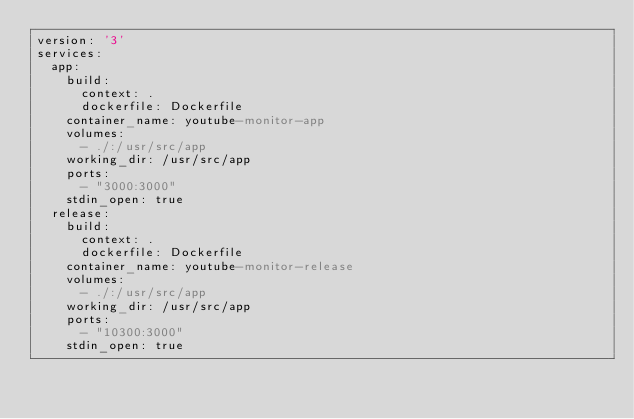<code> <loc_0><loc_0><loc_500><loc_500><_YAML_>version: '3'
services:
  app:
    build:
      context: .
      dockerfile: Dockerfile
    container_name: youtube-monitor-app
    volumes:
      - ./:/usr/src/app
    working_dir: /usr/src/app
    ports:
      - "3000:3000"
    stdin_open: true
  release:
    build:
      context: .
      dockerfile: Dockerfile
    container_name: youtube-monitor-release
    volumes:
      - ./:/usr/src/app
    working_dir: /usr/src/app
    ports:
      - "10300:3000"
    stdin_open: true
</code> 